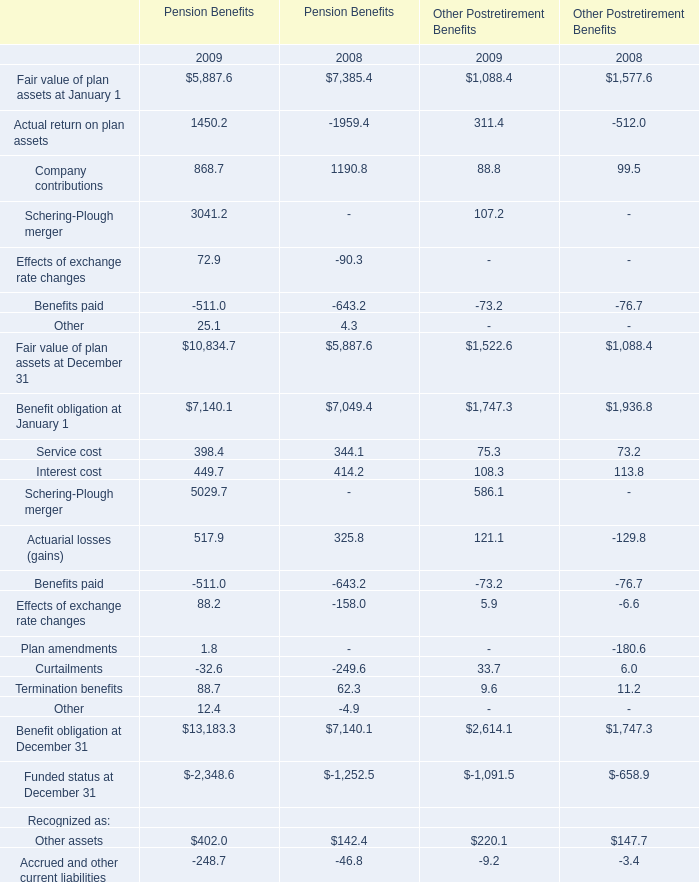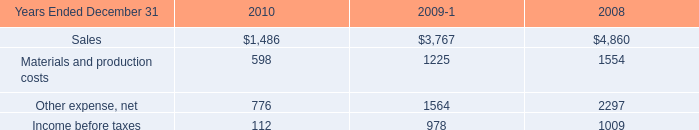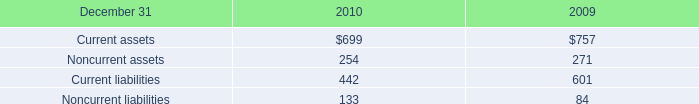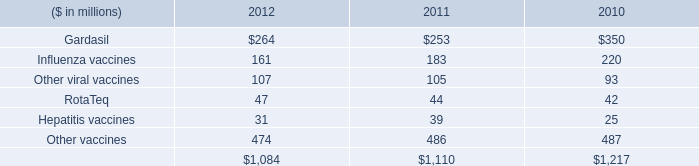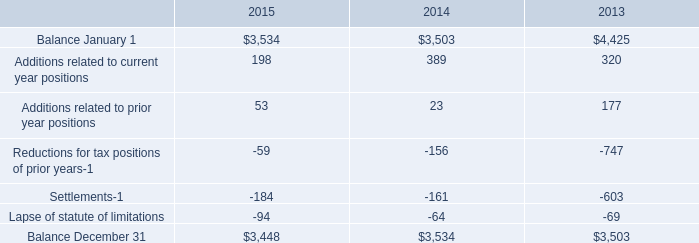What's the sum of Balance December 31 of 2015, Company contributions of Pension Benefits 2008, and Income before taxes of 2008 ? 
Computations: ((3448.0 + 1190.8) + 1009.0)
Answer: 5647.8. 